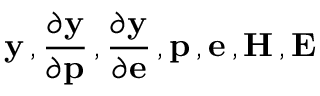<formula> <loc_0><loc_0><loc_500><loc_500>y \, , \frac { \partial y } { \partial p } \, , \frac { \partial y } { \partial e } \, , p \, , e \, , H \, , E</formula> 